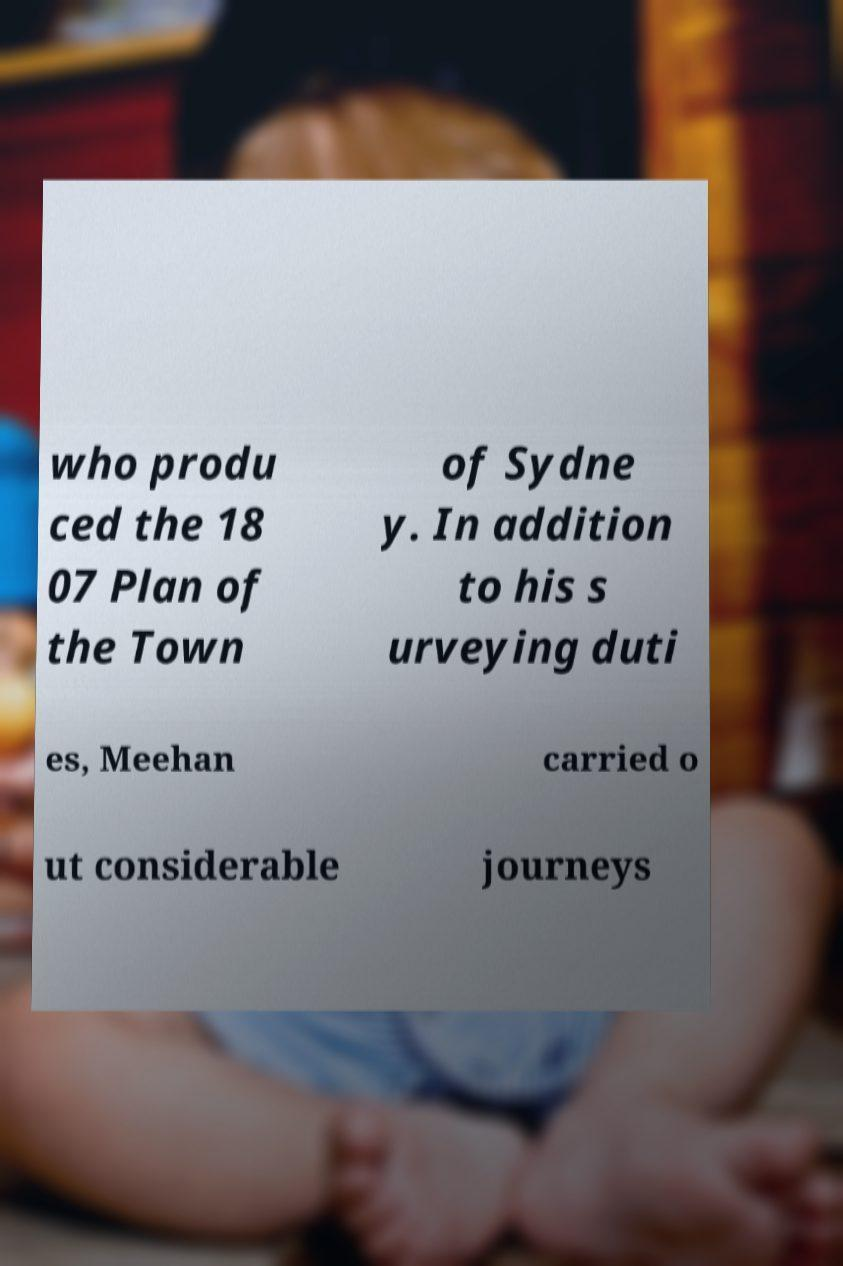Could you assist in decoding the text presented in this image and type it out clearly? who produ ced the 18 07 Plan of the Town of Sydne y. In addition to his s urveying duti es, Meehan carried o ut considerable journeys 